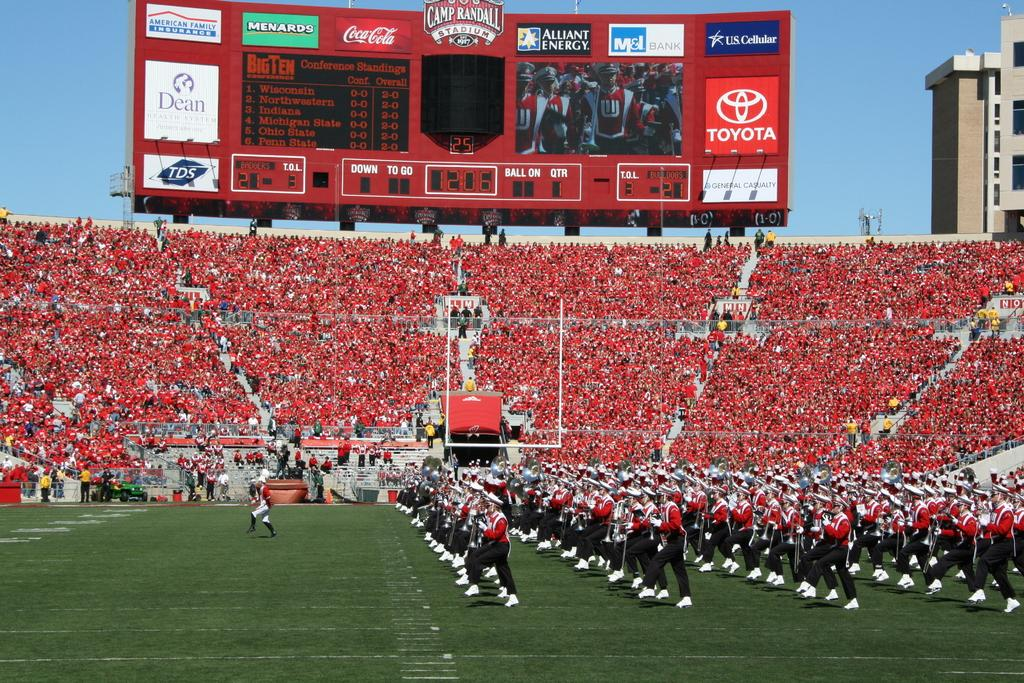Provide a one-sentence caption for the provided image. a football game with Toyota on the scoreboard. 